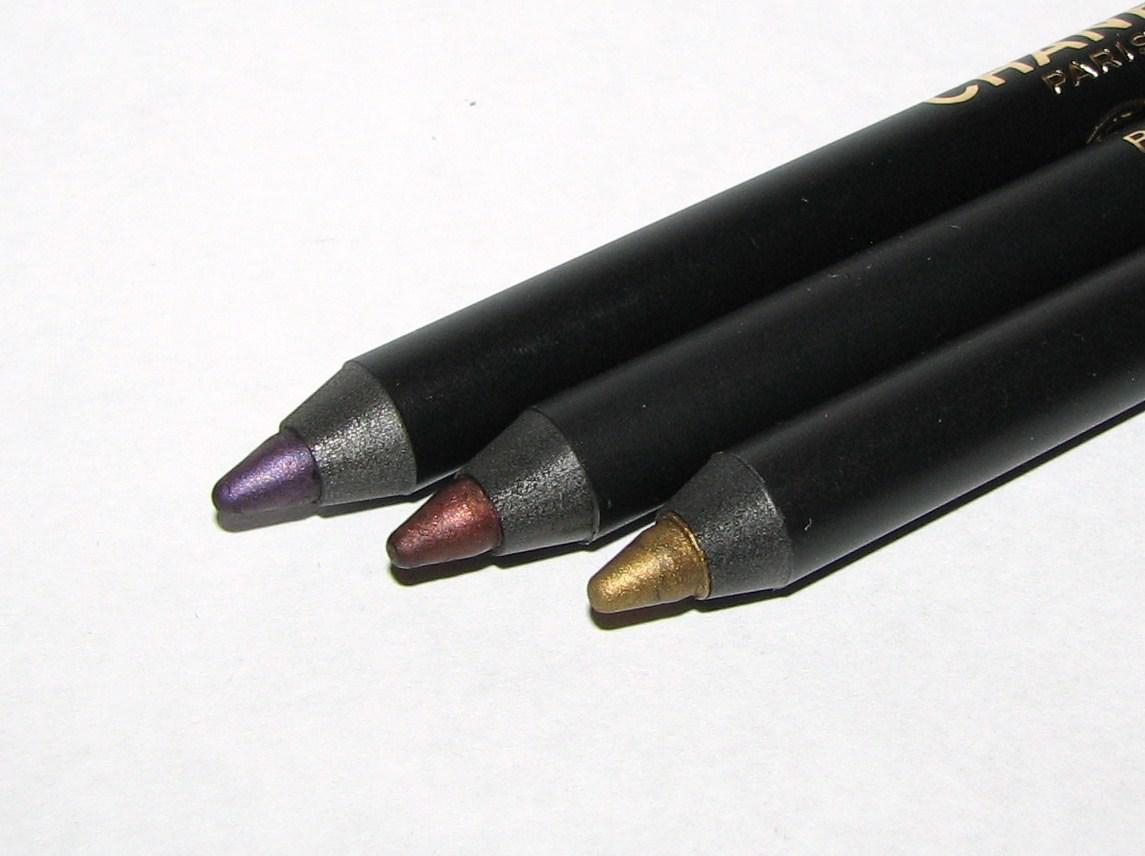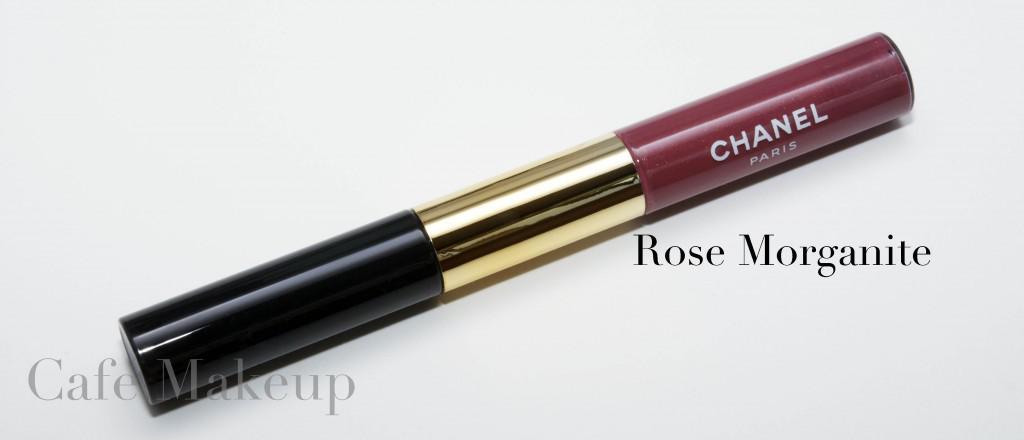The first image is the image on the left, the second image is the image on the right. Analyze the images presented: Is the assertion "All lip makeups shown come in cylindrical bottles with clear glass that shows the reddish-purple color of the lip tint." valid? Answer yes or no. No. The first image is the image on the left, the second image is the image on the right. For the images displayed, is the sentence "All the items are capped." factually correct? Answer yes or no. No. 